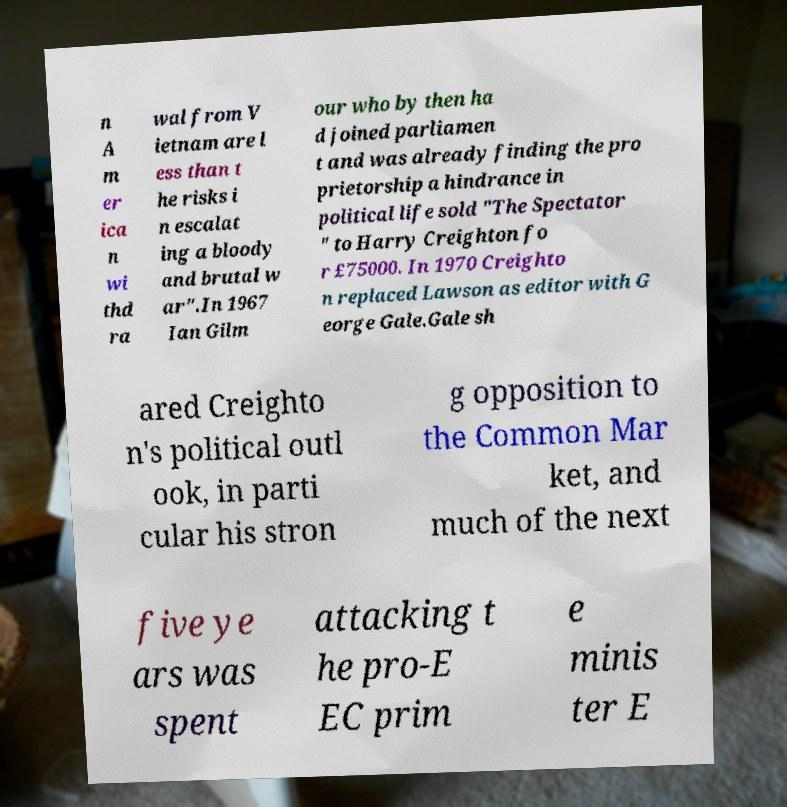Please identify and transcribe the text found in this image. n A m er ica n wi thd ra wal from V ietnam are l ess than t he risks i n escalat ing a bloody and brutal w ar".In 1967 Ian Gilm our who by then ha d joined parliamen t and was already finding the pro prietorship a hindrance in political life sold "The Spectator " to Harry Creighton fo r £75000. In 1970 Creighto n replaced Lawson as editor with G eorge Gale.Gale sh ared Creighto n's political outl ook, in parti cular his stron g opposition to the Common Mar ket, and much of the next five ye ars was spent attacking t he pro-E EC prim e minis ter E 